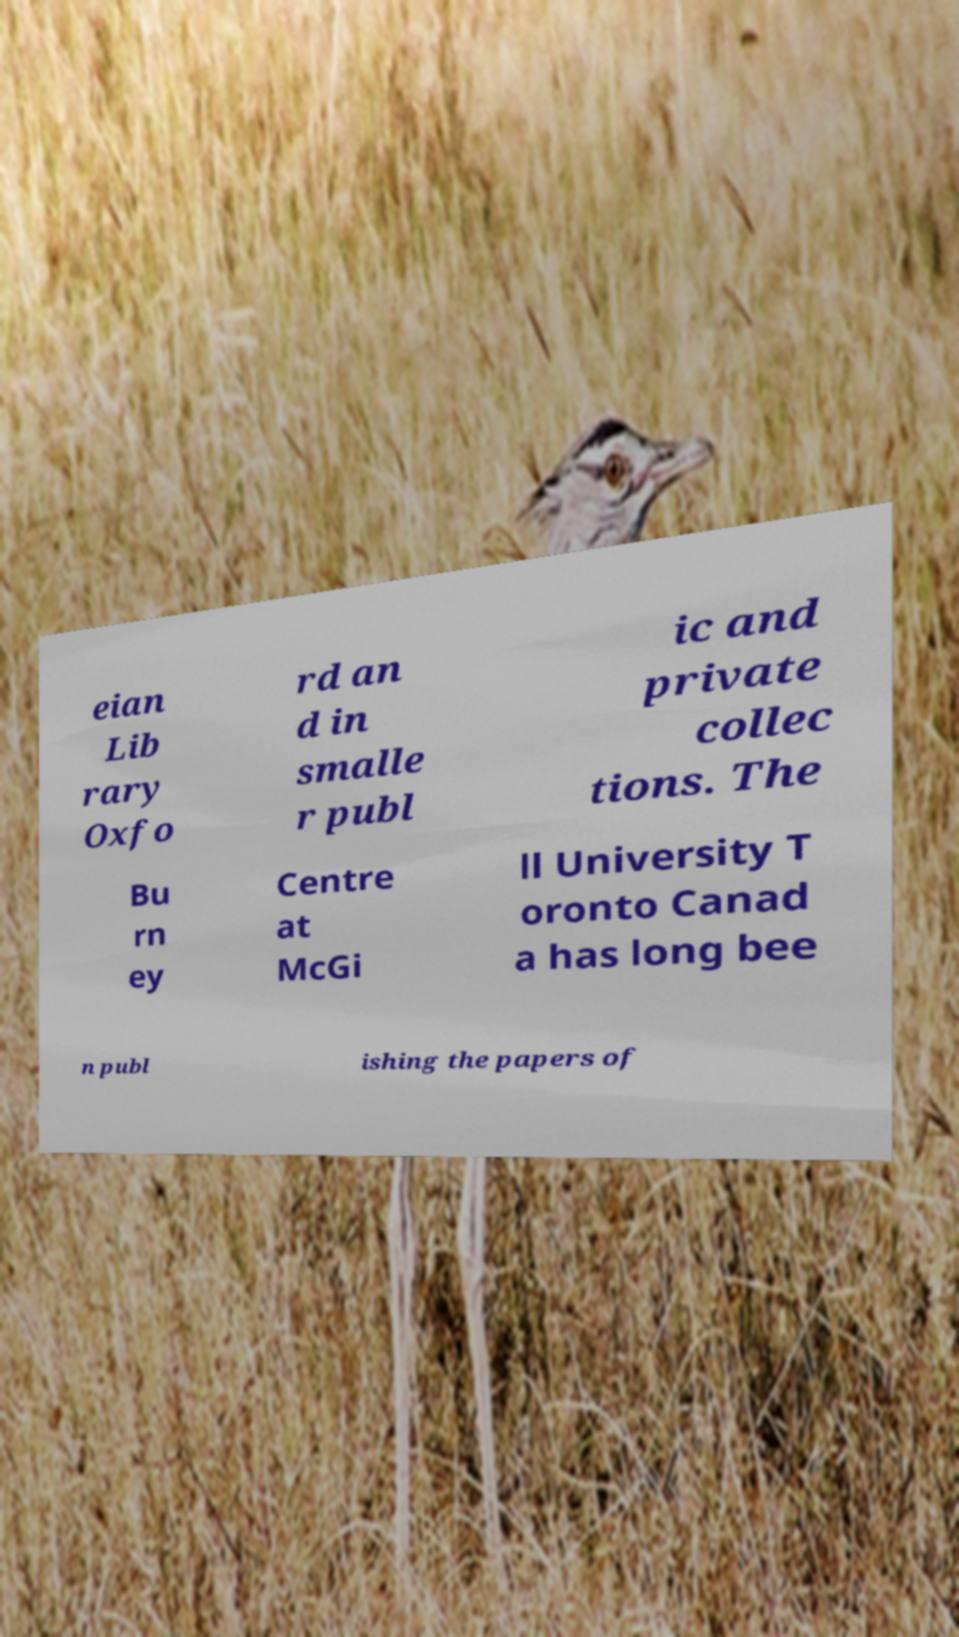There's text embedded in this image that I need extracted. Can you transcribe it verbatim? eian Lib rary Oxfo rd an d in smalle r publ ic and private collec tions. The Bu rn ey Centre at McGi ll University T oronto Canad a has long bee n publ ishing the papers of 